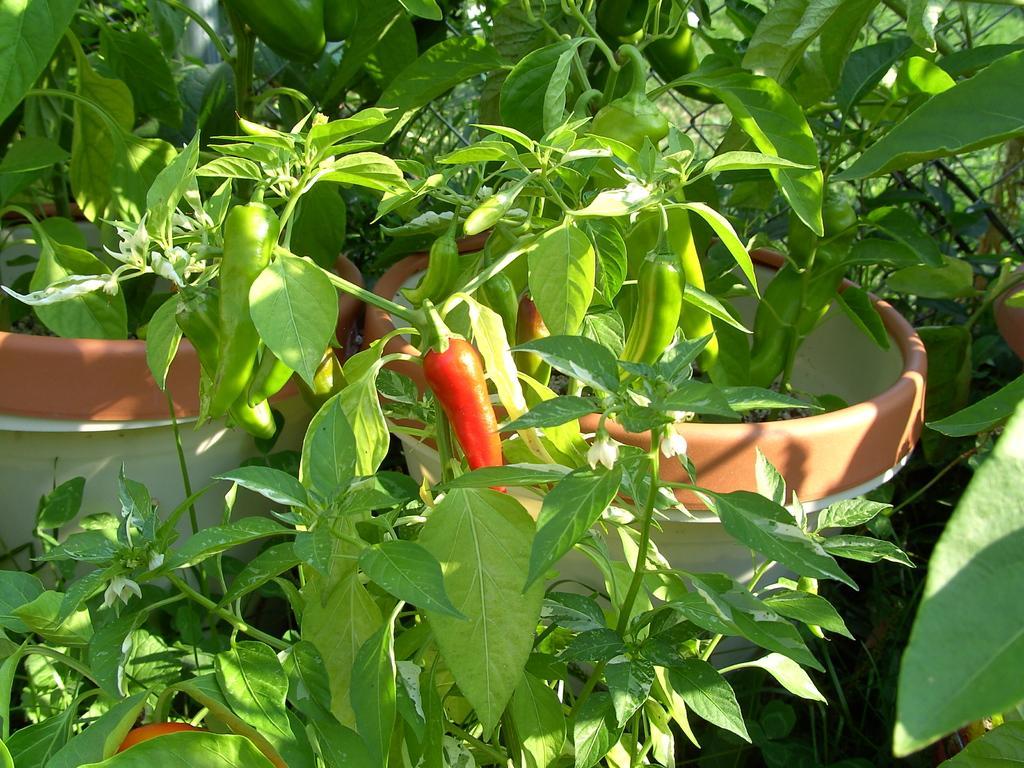Please provide a concise description of this image. In this image, I can see chili's to the plants, which are in the flower pots. 